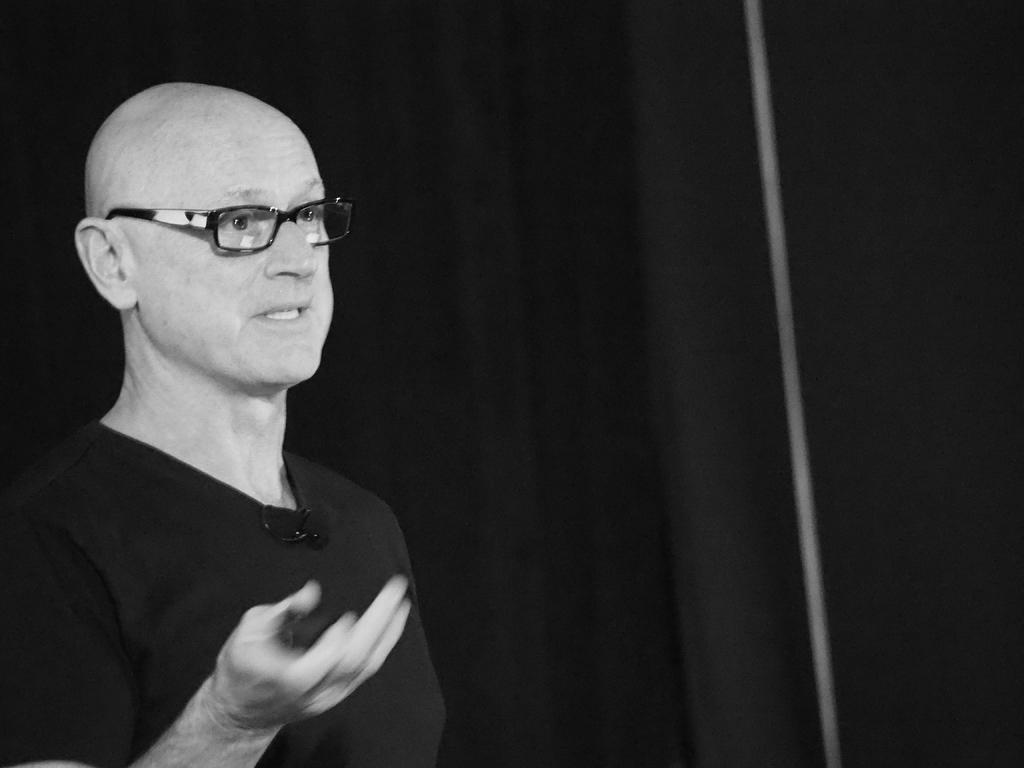Describe this image in one or two sentences. In this image on the left side there is one man is wearing spectacles and talking, and in the background there is a black curtain. 